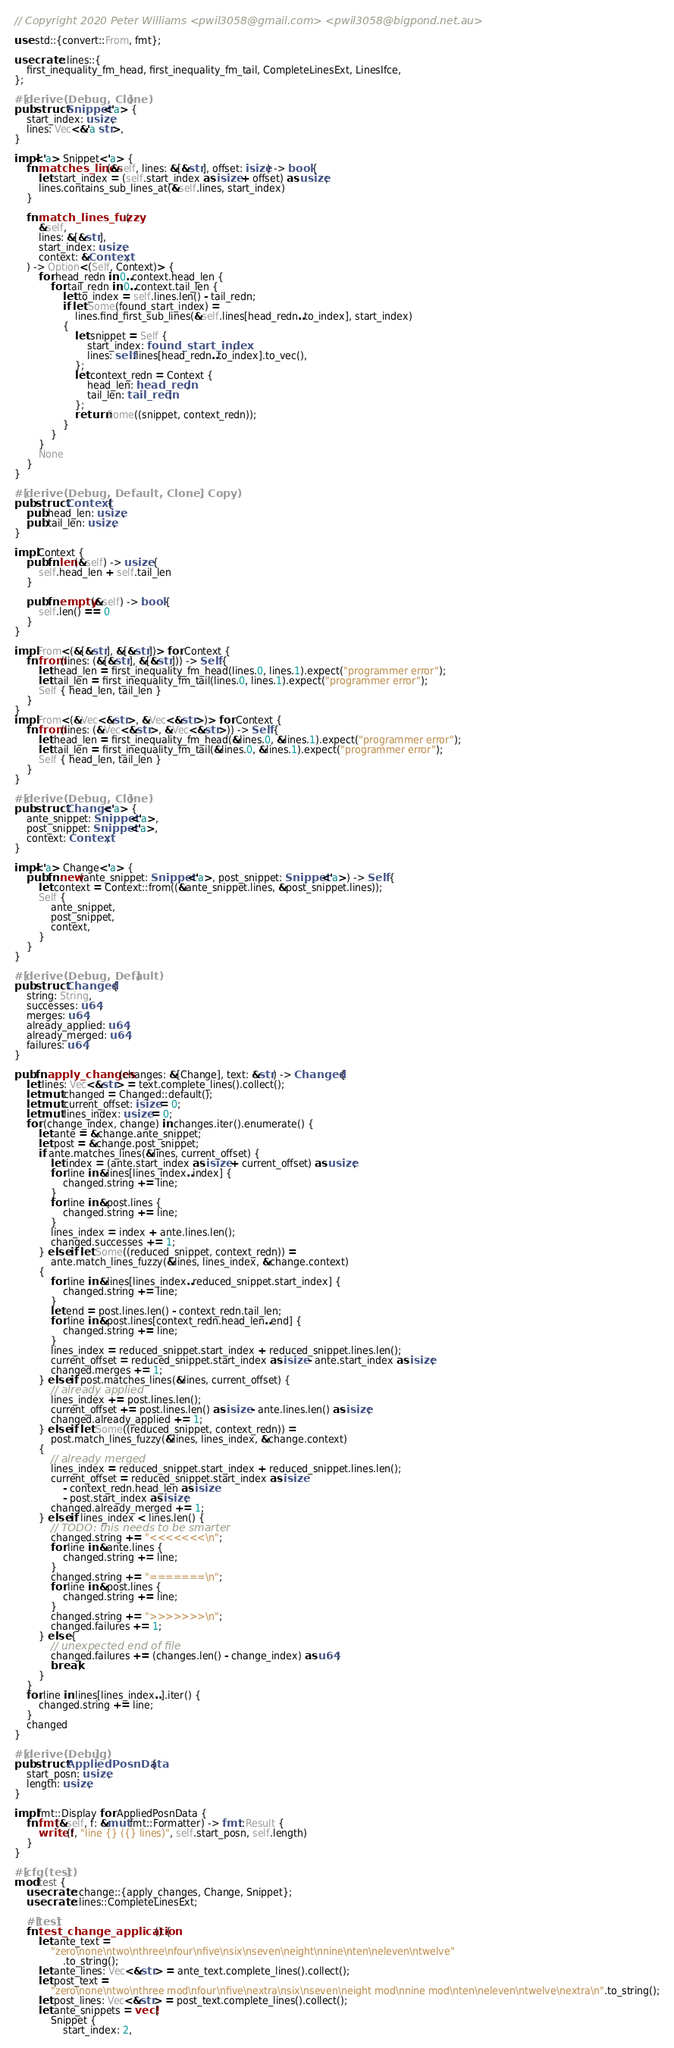Convert code to text. <code><loc_0><loc_0><loc_500><loc_500><_Rust_>// Copyright 2020 Peter Williams <pwil3058@gmail.com> <pwil3058@bigpond.net.au>

use std::{convert::From, fmt};

use crate::lines::{
    first_inequality_fm_head, first_inequality_fm_tail, CompleteLinesExt, LinesIfce,
};

#[derive(Debug, Clone)]
pub struct Snippet<'a> {
    start_index: usize,
    lines: Vec<&'a str>,
}

impl<'a> Snippet<'a> {
    fn matches_lines(&self, lines: &[&str], offset: isize) -> bool {
        let start_index = (self.start_index as isize + offset) as usize;
        lines.contains_sub_lines_at(&self.lines, start_index)
    }

    fn match_lines_fuzzy(
        &self,
        lines: &[&str],
        start_index: usize,
        context: &Context,
    ) -> Option<(Self, Context)> {
        for head_redn in 0..context.head_len {
            for tail_redn in 0..context.tail_len {
                let to_index = self.lines.len() - tail_redn;
                if let Some(found_start_index) =
                    lines.find_first_sub_lines(&self.lines[head_redn..to_index], start_index)
                {
                    let snippet = Self {
                        start_index: found_start_index,
                        lines: self.lines[head_redn..to_index].to_vec(),
                    };
                    let context_redn = Context {
                        head_len: head_redn,
                        tail_len: tail_redn,
                    };
                    return Some((snippet, context_redn));
                }
            }
        }
        None
    }
}

#[derive(Debug, Default, Clone, Copy)]
pub struct Context {
    pub head_len: usize,
    pub tail_len: usize,
}

impl Context {
    pub fn len(&self) -> usize {
        self.head_len + self.tail_len
    }

    pub fn empty(&self) -> bool {
        self.len() == 0
    }
}

impl From<(&[&str], &[&str])> for Context {
    fn from(lines: (&[&str], &[&str])) -> Self {
        let head_len = first_inequality_fm_head(lines.0, lines.1).expect("programmer error");
        let tail_len = first_inequality_fm_tail(lines.0, lines.1).expect("programmer error");
        Self { head_len, tail_len }
    }
}
impl From<(&Vec<&str>, &Vec<&str>)> for Context {
    fn from(lines: (&Vec<&str>, &Vec<&str>)) -> Self {
        let head_len = first_inequality_fm_head(&lines.0, &lines.1).expect("programmer error");
        let tail_len = first_inequality_fm_tail(&lines.0, &lines.1).expect("programmer error");
        Self { head_len, tail_len }
    }
}

#[derive(Debug, Clone)]
pub struct Change<'a> {
    ante_snippet: Snippet<'a>,
    post_snippet: Snippet<'a>,
    context: Context,
}

impl<'a> Change<'a> {
    pub fn new(ante_snippet: Snippet<'a>, post_snippet: Snippet<'a>) -> Self {
        let context = Context::from((&ante_snippet.lines, &post_snippet.lines));
        Self {
            ante_snippet,
            post_snippet,
            context,
        }
    }
}

#[derive(Debug, Default)]
pub struct Changed {
    string: String,
    successes: u64,
    merges: u64,
    already_applied: u64,
    already_merged: u64,
    failures: u64,
}

pub fn apply_changes(changes: &[Change], text: &str) -> Changed {
    let lines: Vec<&str> = text.complete_lines().collect();
    let mut changed = Changed::default();
    let mut current_offset: isize = 0;
    let mut lines_index: usize = 0;
    for (change_index, change) in changes.iter().enumerate() {
        let ante = &change.ante_snippet;
        let post = &change.post_snippet;
        if ante.matches_lines(&lines, current_offset) {
            let index = (ante.start_index as isize + current_offset) as usize;
            for line in &lines[lines_index..index] {
                changed.string += line;
            }
            for line in &post.lines {
                changed.string += line;
            }
            lines_index = index + ante.lines.len();
            changed.successes += 1;
        } else if let Some((reduced_snippet, context_redn)) =
            ante.match_lines_fuzzy(&lines, lines_index, &change.context)
        {
            for line in &lines[lines_index..reduced_snippet.start_index] {
                changed.string += line;
            }
            let end = post.lines.len() - context_redn.tail_len;
            for line in &post.lines[context_redn.head_len..end] {
                changed.string += line;
            }
            lines_index = reduced_snippet.start_index + reduced_snippet.lines.len();
            current_offset = reduced_snippet.start_index as isize - ante.start_index as isize;
            changed.merges += 1;
        } else if post.matches_lines(&lines, current_offset) {
            // already applied
            lines_index += post.lines.len();
            current_offset += post.lines.len() as isize - ante.lines.len() as isize;
            changed.already_applied += 1;
        } else if let Some((reduced_snippet, context_redn)) =
            post.match_lines_fuzzy(&lines, lines_index, &change.context)
        {
            // already merged
            lines_index = reduced_snippet.start_index + reduced_snippet.lines.len();
            current_offset = reduced_snippet.start_index as isize
                - context_redn.head_len as isize
                - post.start_index as isize;
            changed.already_merged += 1;
        } else if lines_index < lines.len() {
            // TODO: this needs to be smarter
            changed.string += "<<<<<<<\n";
            for line in &ante.lines {
                changed.string += line;
            }
            changed.string += "=======\n";
            for line in &post.lines {
                changed.string += line;
            }
            changed.string += ">>>>>>>\n";
            changed.failures += 1;
        } else {
            // unexpected end of file
            changed.failures += (changes.len() - change_index) as u64;
            break;
        }
    }
    for line in lines[lines_index..].iter() {
        changed.string += line;
    }
    changed
}

#[derive(Debug)]
pub struct AppliedPosnData {
    start_posn: usize,
    length: usize,
}

impl fmt::Display for AppliedPosnData {
    fn fmt(&self, f: &mut fmt::Formatter) -> fmt::Result {
        write!(f, "line {} ({} lines)", self.start_posn, self.length)
    }
}

#[cfg(test)]
mod test {
    use crate::change::{apply_changes, Change, Snippet};
    use crate::lines::CompleteLinesExt;

    #[test]
    fn test_change_application() {
        let ante_text =
            "zero\none\ntwo\nthree\nfour\nfive\nsix\nseven\neight\nnine\nten\neleven\ntwelve"
                .to_string();
        let ante_lines: Vec<&str> = ante_text.complete_lines().collect();
        let post_text =
            "zero\none\ntwo\nthree mod\nfour\nfive\nextra\nsix\nseven\neight mod\nnine mod\nten\neleven\ntwelve\nextra\n".to_string();
        let post_lines: Vec<&str> = post_text.complete_lines().collect();
        let ante_snippets = vec![
            Snippet {
                start_index: 2,</code> 